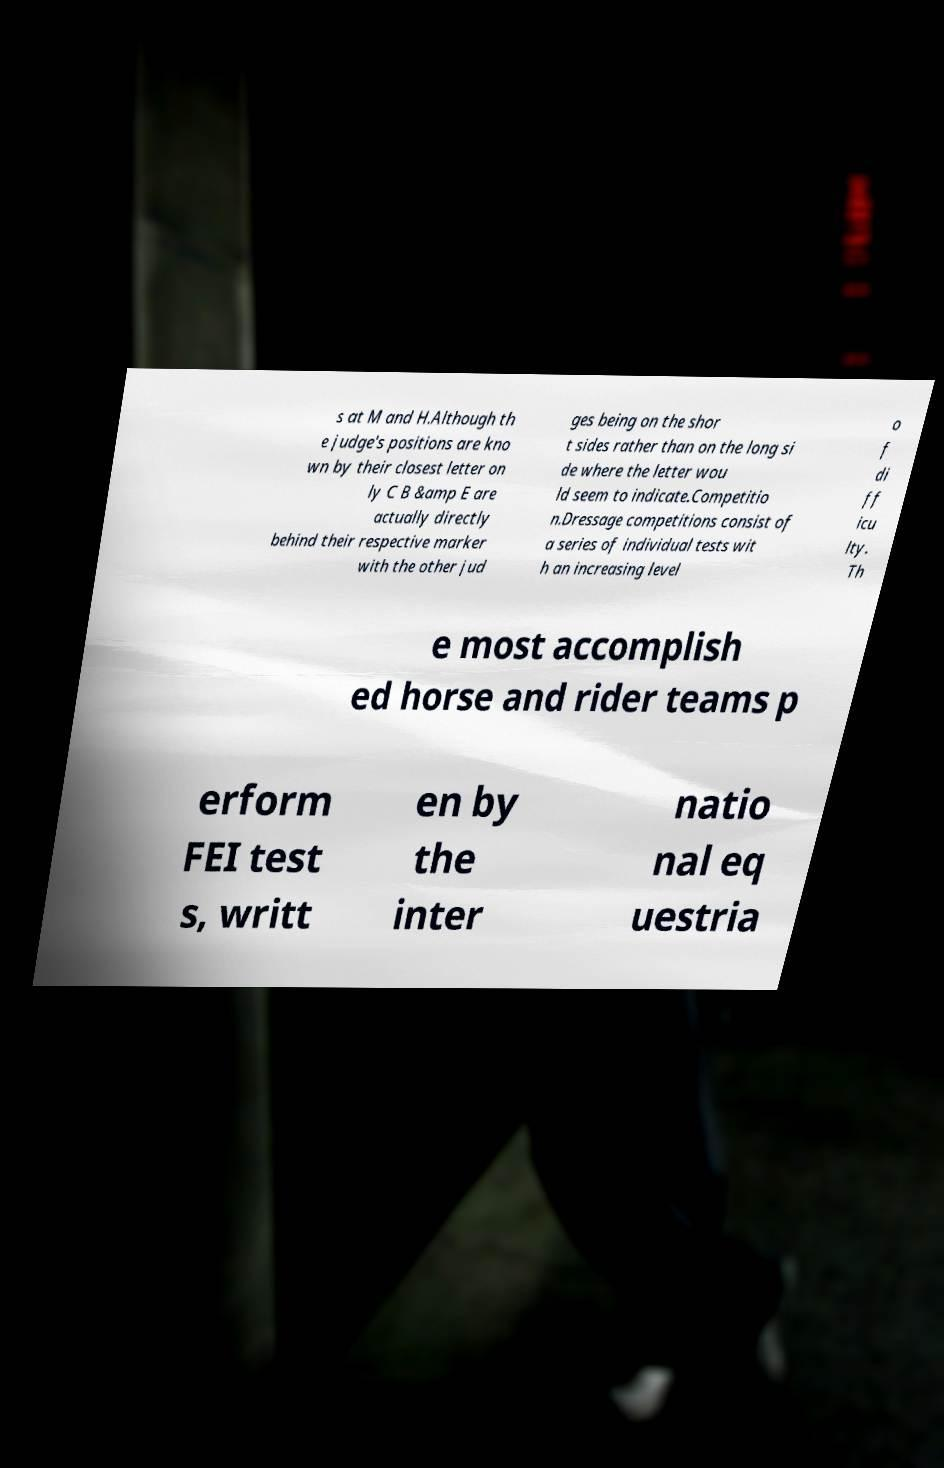Could you extract and type out the text from this image? s at M and H.Although th e judge's positions are kno wn by their closest letter on ly C B &amp E are actually directly behind their respective marker with the other jud ges being on the shor t sides rather than on the long si de where the letter wou ld seem to indicate.Competitio n.Dressage competitions consist of a series of individual tests wit h an increasing level o f di ff icu lty. Th e most accomplish ed horse and rider teams p erform FEI test s, writt en by the inter natio nal eq uestria 